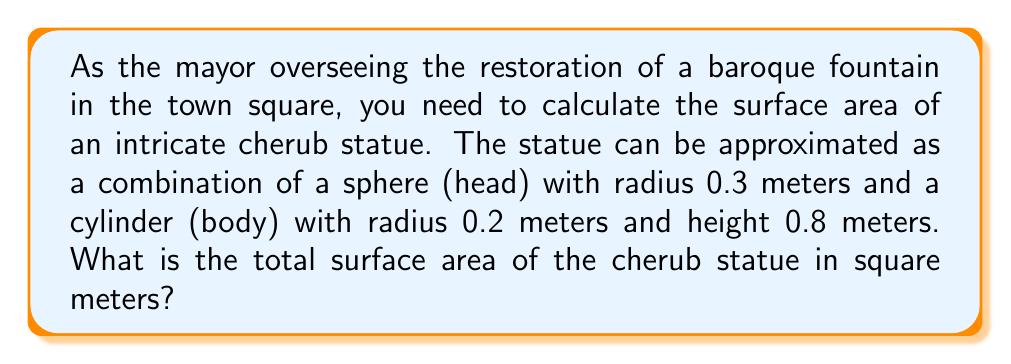Teach me how to tackle this problem. To solve this problem, we need to calculate the surface areas of the sphere and cylinder separately, then add them together.

1. Surface area of the sphere (head):
   The formula for the surface area of a sphere is $A_s = 4\pi r^2$
   $$A_s = 4\pi (0.3)^2 = 4\pi (0.09) = 1.13097335529 \text{ m}^2$$

2. Surface area of the cylinder (body):
   The formula for the surface area of a cylinder is $A_c = 2\pi r h + 2\pi r^2$
   $$A_c = 2\pi (0.2)(0.8) + 2\pi (0.2)^2$$
   $$A_c = 1.00530964914 + 0.25132741228 = 1.25663706142 \text{ m}^2$$

3. Total surface area:
   $$A_\text{total} = A_s + A_c = 1.13097335529 + 1.25663706142 = 2.38761041671 \text{ m}^2$$

Rounding to two decimal places for practical purposes:
$$A_\text{total} \approx 2.39 \text{ m}^2$$
Answer: 2.39 m² 